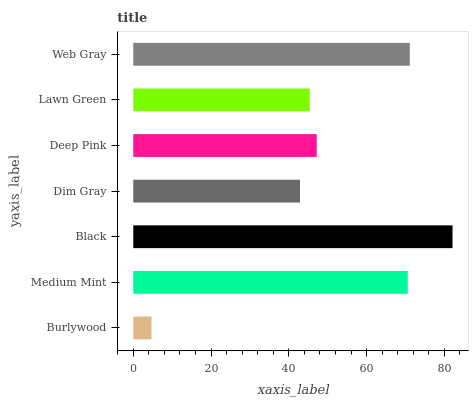Is Burlywood the minimum?
Answer yes or no. Yes. Is Black the maximum?
Answer yes or no. Yes. Is Medium Mint the minimum?
Answer yes or no. No. Is Medium Mint the maximum?
Answer yes or no. No. Is Medium Mint greater than Burlywood?
Answer yes or no. Yes. Is Burlywood less than Medium Mint?
Answer yes or no. Yes. Is Burlywood greater than Medium Mint?
Answer yes or no. No. Is Medium Mint less than Burlywood?
Answer yes or no. No. Is Deep Pink the high median?
Answer yes or no. Yes. Is Deep Pink the low median?
Answer yes or no. Yes. Is Burlywood the high median?
Answer yes or no. No. Is Web Gray the low median?
Answer yes or no. No. 